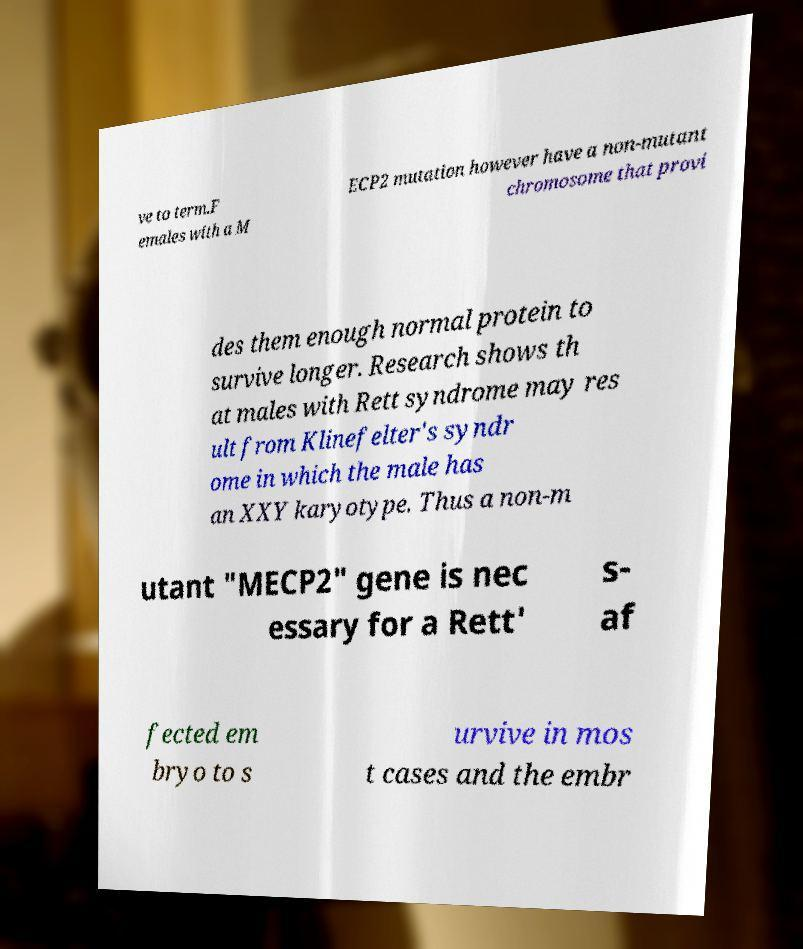For documentation purposes, I need the text within this image transcribed. Could you provide that? ve to term.F emales with a M ECP2 mutation however have a non-mutant chromosome that provi des them enough normal protein to survive longer. Research shows th at males with Rett syndrome may res ult from Klinefelter's syndr ome in which the male has an XXY karyotype. Thus a non-m utant "MECP2" gene is nec essary for a Rett' s- af fected em bryo to s urvive in mos t cases and the embr 